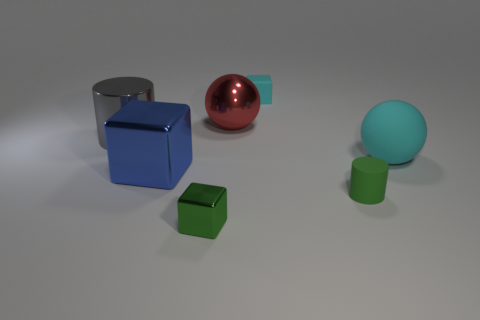Add 2 tiny things. How many objects exist? 9 Subtract all rubber cylinders. Subtract all green cylinders. How many objects are left? 5 Add 2 small green blocks. How many small green blocks are left? 3 Add 7 big gray cylinders. How many big gray cylinders exist? 8 Subtract 0 brown cubes. How many objects are left? 7 Subtract all cubes. How many objects are left? 4 